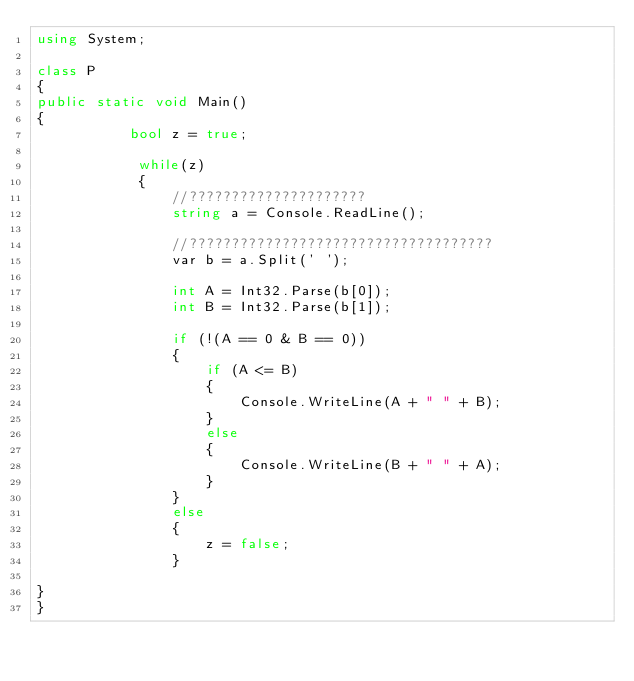<code> <loc_0><loc_0><loc_500><loc_500><_C#_>using System;

class P
{
public static void Main()
{
           bool z = true;
            
            while(z)
            {
                //?????????????????????
                string a = Console.ReadLine();

                //????????????????????????????????????
                var b = a.Split(' ');

                int A = Int32.Parse(b[0]);
                int B = Int32.Parse(b[1]);

                if (!(A == 0 & B == 0))
                {
                    if (A <= B)
                    {
                        Console.WriteLine(A + " " + B);
                    }
                    else
                    {
                        Console.WriteLine(B + " " + A);
                    }
                }
                else
                {
                    z = false;
                }

}
}</code> 